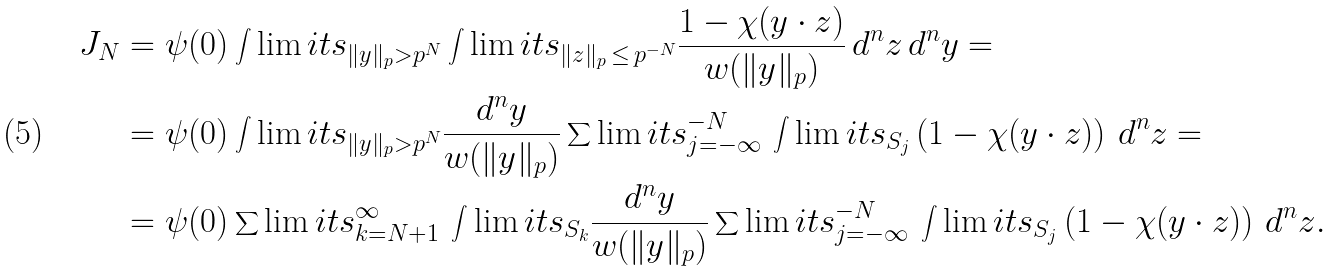Convert formula to latex. <formula><loc_0><loc_0><loc_500><loc_500>J _ { N } & = \psi ( 0 ) \int \lim i t s _ { \| y \| _ { p } > p ^ { N } } \int \lim i t s _ { \| z \| _ { p } \, \leq \, p ^ { - N } } \frac { 1 - \chi ( y \cdot z ) } { w ( \| y \| _ { p } ) } \, d ^ { n } z \, d ^ { n } y = \\ & = \psi ( 0 ) \int \lim i t s _ { \| y \| _ { p } > p ^ { N } } \frac { d ^ { n } y } { w ( \| y \| _ { p } ) } \sum \lim i t s _ { j = - \infty } ^ { - N } \, \int \lim i t s _ { S _ { j } } \left ( 1 - \chi ( y \cdot z ) \right ) \, d ^ { n } z = \\ & = \psi ( 0 ) \sum \lim i t s _ { k = N + 1 } ^ { \infty } \, \int \lim i t s _ { S _ { k } } \frac { d ^ { n } y } { w ( \| y \| _ { p } ) } \sum \lim i t s _ { j = - \infty } ^ { - N } \, \int \lim i t s _ { S _ { j } } \left ( 1 - \chi ( y \cdot z ) \right ) \, d ^ { n } z .</formula> 